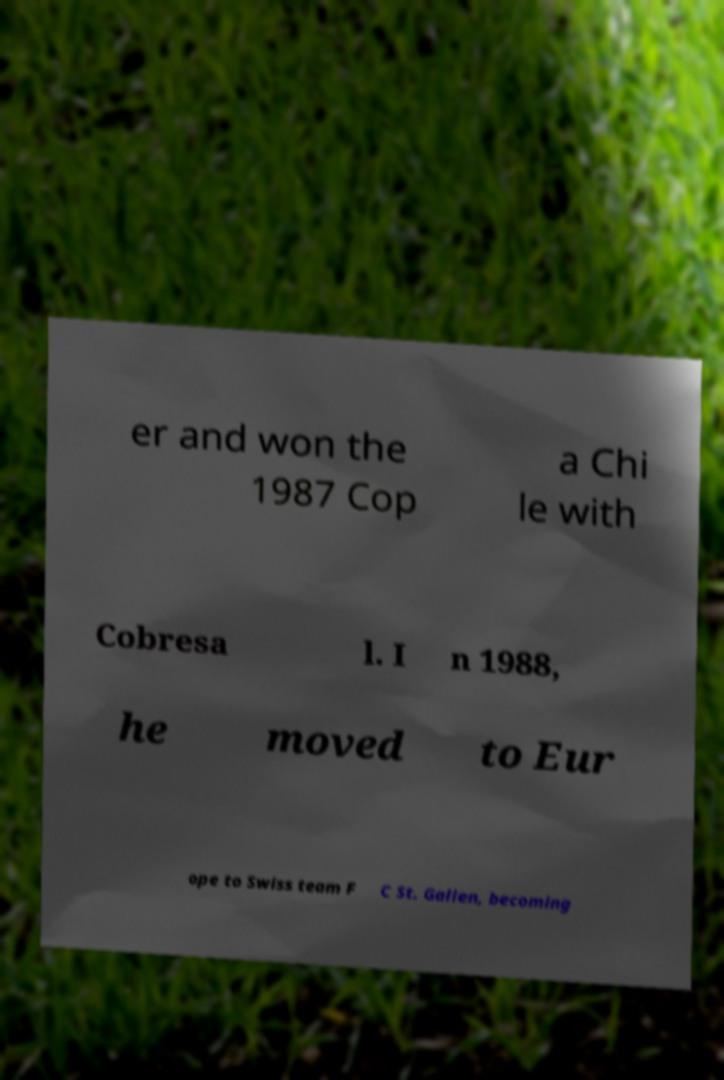I need the written content from this picture converted into text. Can you do that? er and won the 1987 Cop a Chi le with Cobresa l. I n 1988, he moved to Eur ope to Swiss team F C St. Gallen, becoming 